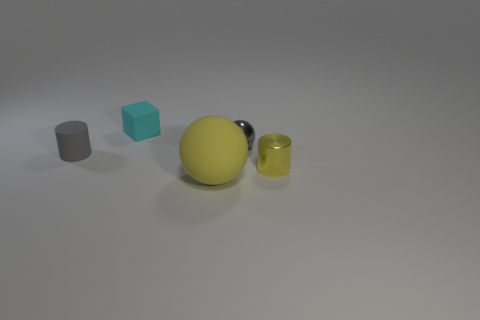Is there anything else that has the same size as the yellow matte thing?
Keep it short and to the point. No. The other matte object that is the same size as the cyan matte thing is what color?
Make the answer very short. Gray. There is a small rubber block; what number of rubber objects are left of it?
Make the answer very short. 1. Are there any large yellow things that have the same material as the cyan cube?
Provide a succinct answer. Yes. There is a matte object that is the same color as the metallic cylinder; what shape is it?
Give a very brief answer. Sphere. There is a tiny shiny object that is behind the tiny gray rubber cylinder; what color is it?
Keep it short and to the point. Gray. Is the number of gray matte objects on the right side of the small matte cylinder the same as the number of metal things that are right of the small gray shiny thing?
Keep it short and to the point. No. What material is the ball that is behind the yellow thing that is behind the big yellow object?
Keep it short and to the point. Metal. How many things are red blocks or small things that are in front of the small cyan rubber object?
Keep it short and to the point. 3. The cylinder that is made of the same material as the tiny cyan thing is what size?
Make the answer very short. Small. 